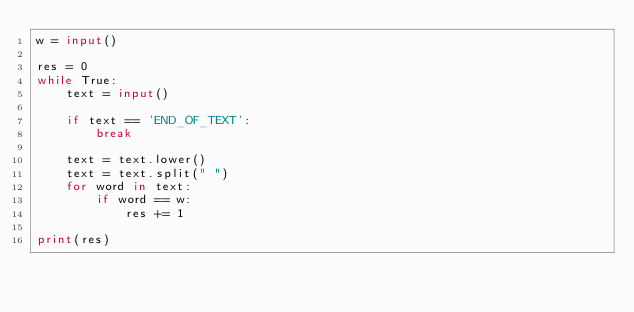<code> <loc_0><loc_0><loc_500><loc_500><_Python_>w = input()

res = 0
while True:
    text = input()

    if text == 'END_OF_TEXT':
        break

    text = text.lower()
    text = text.split(" ")
    for word in text:
        if word == w:
            res += 1

print(res)

</code> 